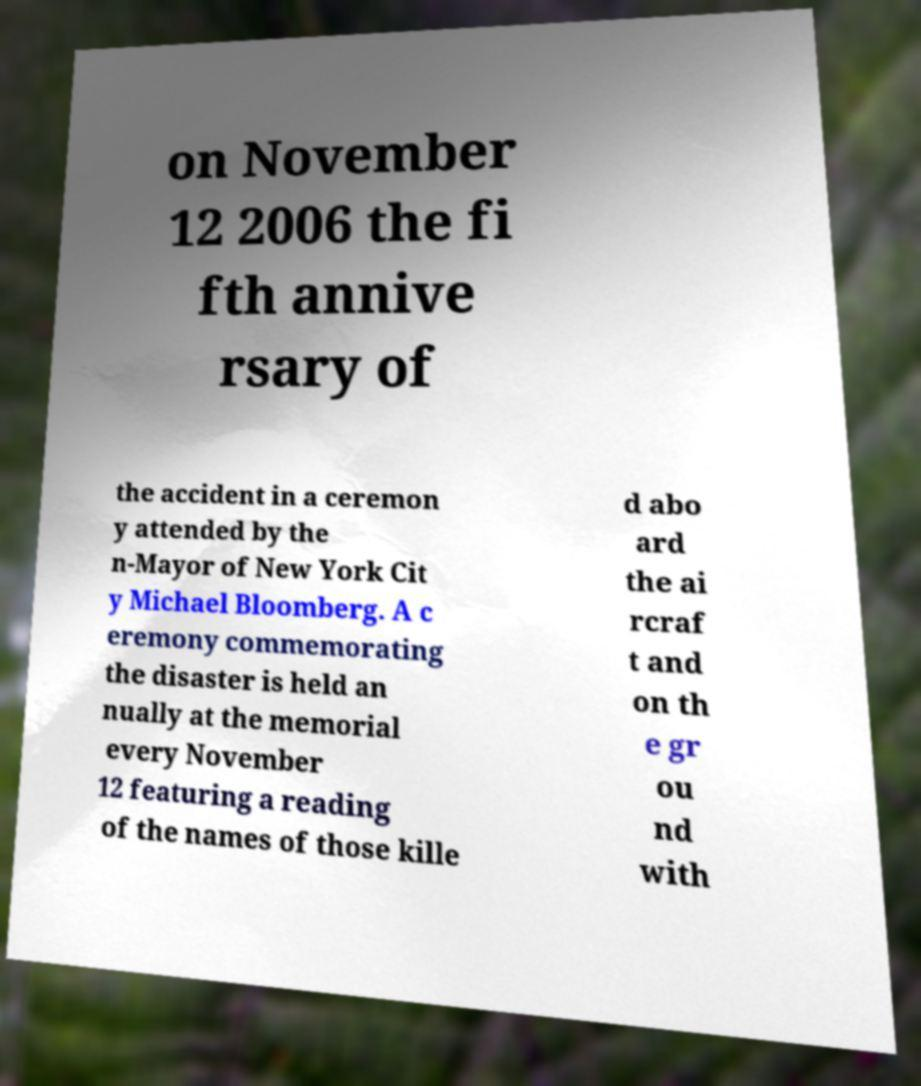Can you accurately transcribe the text from the provided image for me? on November 12 2006 the fi fth annive rsary of the accident in a ceremon y attended by the n-Mayor of New York Cit y Michael Bloomberg. A c eremony commemorating the disaster is held an nually at the memorial every November 12 featuring a reading of the names of those kille d abo ard the ai rcraf t and on th e gr ou nd with 